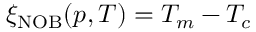Convert formula to latex. <formula><loc_0><loc_0><loc_500><loc_500>\xi _ { N O B } ( p , T ) = T _ { m } - T _ { c }</formula> 